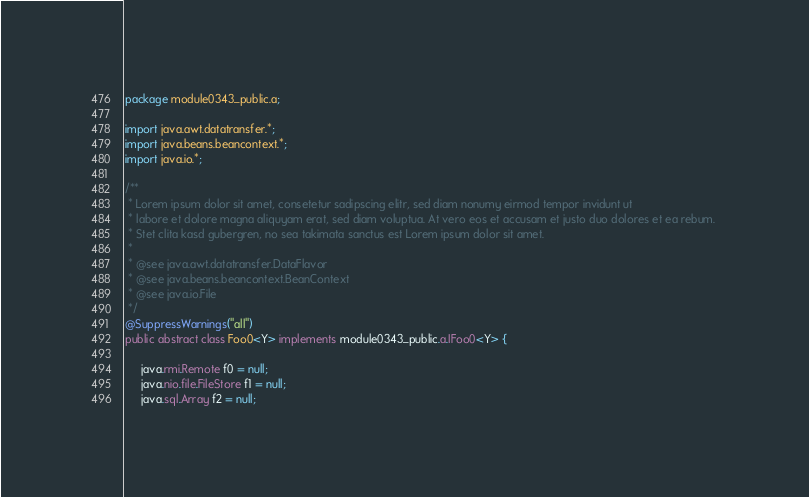<code> <loc_0><loc_0><loc_500><loc_500><_Java_>package module0343_public.a;

import java.awt.datatransfer.*;
import java.beans.beancontext.*;
import java.io.*;

/**
 * Lorem ipsum dolor sit amet, consetetur sadipscing elitr, sed diam nonumy eirmod tempor invidunt ut 
 * labore et dolore magna aliquyam erat, sed diam voluptua. At vero eos et accusam et justo duo dolores et ea rebum. 
 * Stet clita kasd gubergren, no sea takimata sanctus est Lorem ipsum dolor sit amet. 
 *
 * @see java.awt.datatransfer.DataFlavor
 * @see java.beans.beancontext.BeanContext
 * @see java.io.File
 */
@SuppressWarnings("all")
public abstract class Foo0<Y> implements module0343_public.a.IFoo0<Y> {

	 java.rmi.Remote f0 = null;
	 java.nio.file.FileStore f1 = null;
	 java.sql.Array f2 = null;
</code> 